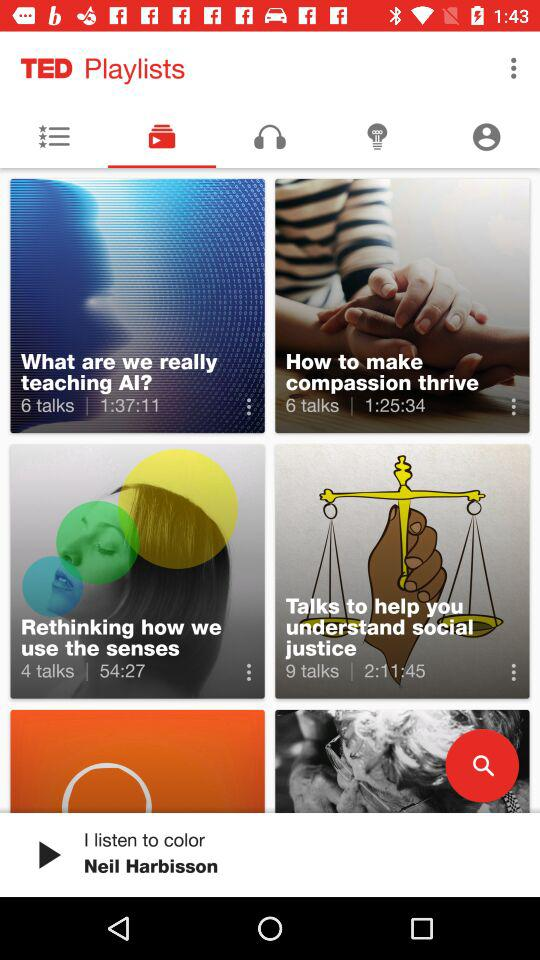What playlist has four talks available? The playlist, which has four talks available, is "Rethinking how we use the senses". 